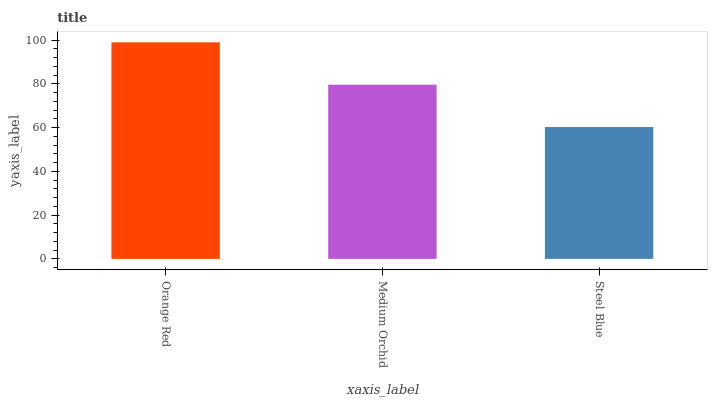Is Steel Blue the minimum?
Answer yes or no. Yes. Is Orange Red the maximum?
Answer yes or no. Yes. Is Medium Orchid the minimum?
Answer yes or no. No. Is Medium Orchid the maximum?
Answer yes or no. No. Is Orange Red greater than Medium Orchid?
Answer yes or no. Yes. Is Medium Orchid less than Orange Red?
Answer yes or no. Yes. Is Medium Orchid greater than Orange Red?
Answer yes or no. No. Is Orange Red less than Medium Orchid?
Answer yes or no. No. Is Medium Orchid the high median?
Answer yes or no. Yes. Is Medium Orchid the low median?
Answer yes or no. Yes. Is Steel Blue the high median?
Answer yes or no. No. Is Steel Blue the low median?
Answer yes or no. No. 